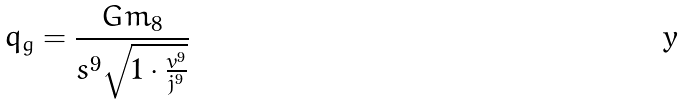<formula> <loc_0><loc_0><loc_500><loc_500>q _ { g } = \frac { G m _ { 8 } } { s ^ { 9 } \sqrt { 1 \cdot \frac { v ^ { 9 } } { j ^ { 9 } } } }</formula> 